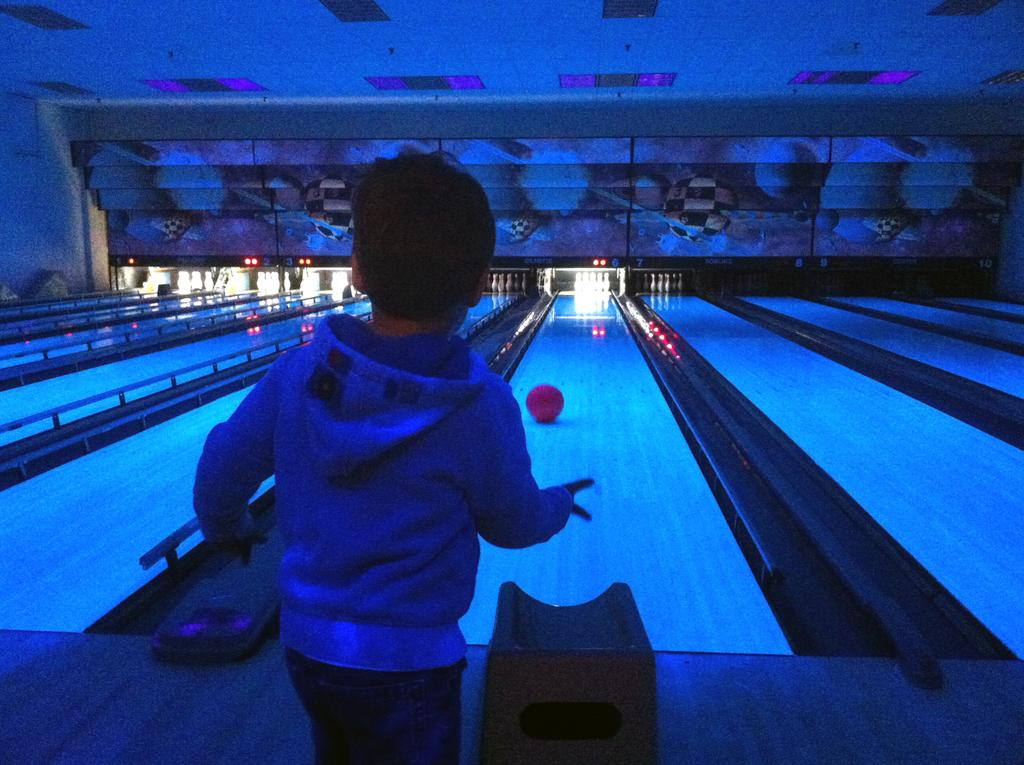What is the main setting of the image? The image is of a room. Who or what can be seen in the foreground of the image? There is a boy standing in the foreground of the image. What object is on the floor in the background of the image? There is a ball on the floor in the background of the image. What else can be seen in the background of the image? There are objects in the background of the image. What can be seen at the top of the image? There are lights visible at the top of the image. What type of snake can be seen slithering across the floor in the image? There is no snake present in the image; it is a room with a boy, a ball, and other objects. 